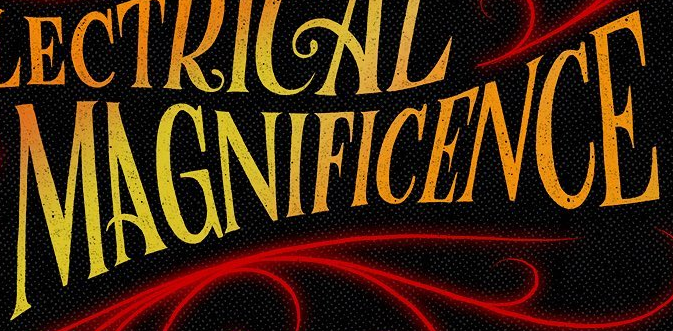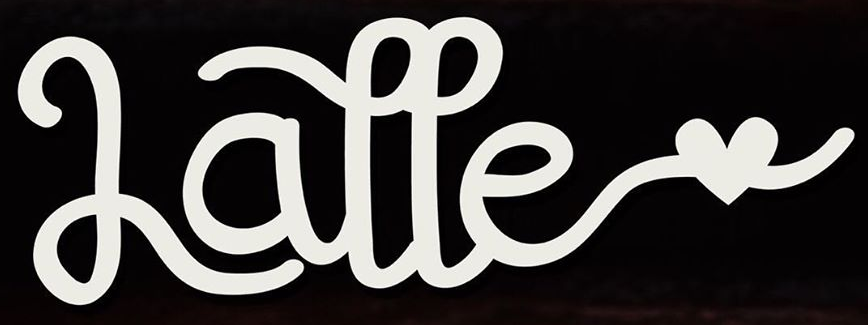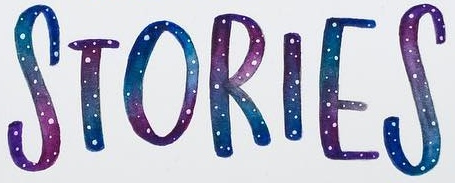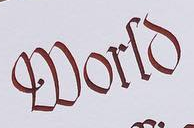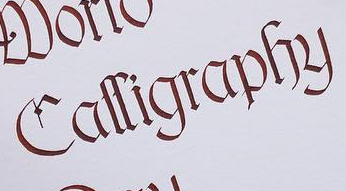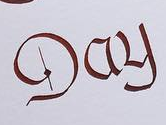What text is displayed in these images sequentially, separated by a semicolon? MAGNIFICENCE; Latte; STORIES; World; Calligraphy; Day 